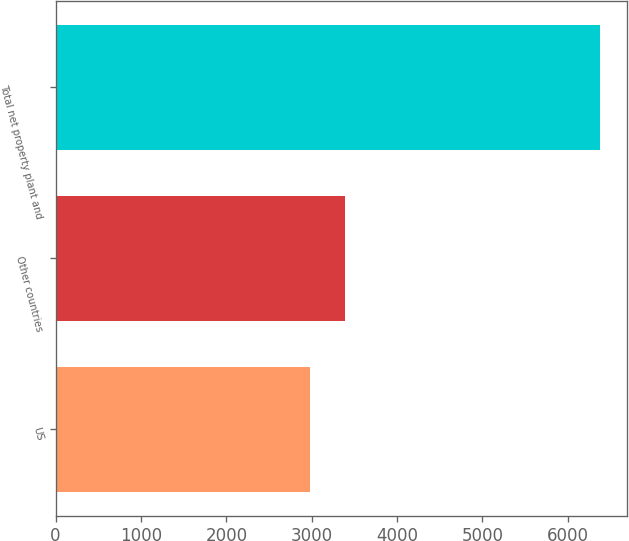Convert chart. <chart><loc_0><loc_0><loc_500><loc_500><bar_chart><fcel>US<fcel>Other countries<fcel>Total net property plant and<nl><fcel>2981<fcel>3394<fcel>6375<nl></chart> 